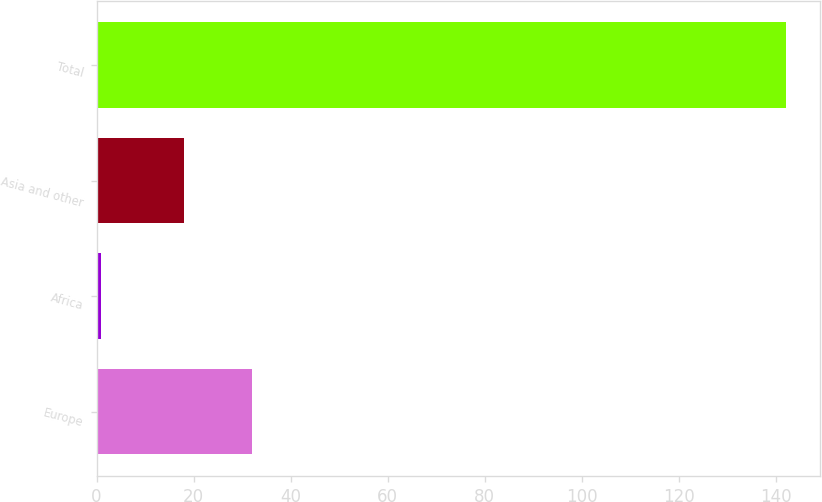Convert chart to OTSL. <chart><loc_0><loc_0><loc_500><loc_500><bar_chart><fcel>Europe<fcel>Africa<fcel>Asia and other<fcel>Total<nl><fcel>32.1<fcel>1<fcel>18<fcel>142<nl></chart> 